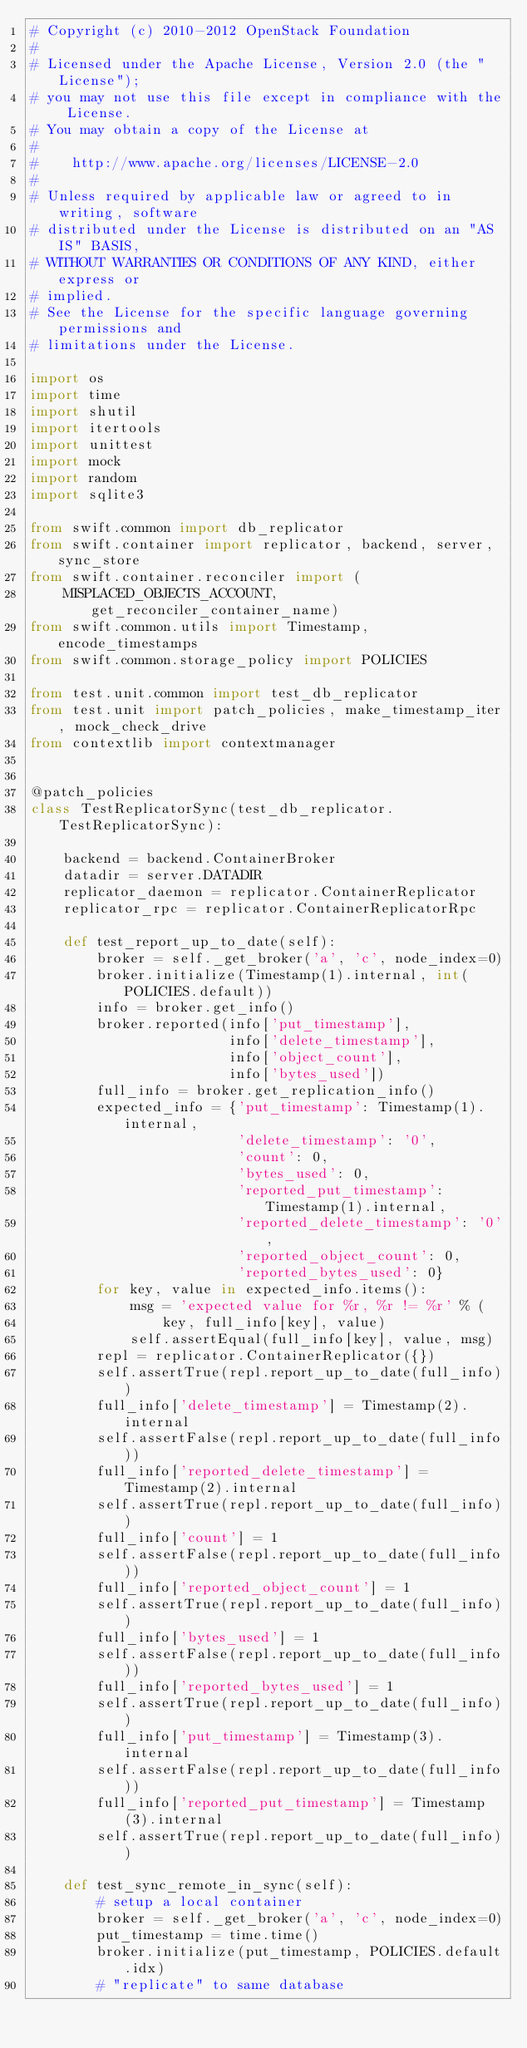Convert code to text. <code><loc_0><loc_0><loc_500><loc_500><_Python_># Copyright (c) 2010-2012 OpenStack Foundation
#
# Licensed under the Apache License, Version 2.0 (the "License");
# you may not use this file except in compliance with the License.
# You may obtain a copy of the License at
#
#    http://www.apache.org/licenses/LICENSE-2.0
#
# Unless required by applicable law or agreed to in writing, software
# distributed under the License is distributed on an "AS IS" BASIS,
# WITHOUT WARRANTIES OR CONDITIONS OF ANY KIND, either express or
# implied.
# See the License for the specific language governing permissions and
# limitations under the License.

import os
import time
import shutil
import itertools
import unittest
import mock
import random
import sqlite3

from swift.common import db_replicator
from swift.container import replicator, backend, server, sync_store
from swift.container.reconciler import (
    MISPLACED_OBJECTS_ACCOUNT, get_reconciler_container_name)
from swift.common.utils import Timestamp, encode_timestamps
from swift.common.storage_policy import POLICIES

from test.unit.common import test_db_replicator
from test.unit import patch_policies, make_timestamp_iter, mock_check_drive
from contextlib import contextmanager


@patch_policies
class TestReplicatorSync(test_db_replicator.TestReplicatorSync):

    backend = backend.ContainerBroker
    datadir = server.DATADIR
    replicator_daemon = replicator.ContainerReplicator
    replicator_rpc = replicator.ContainerReplicatorRpc

    def test_report_up_to_date(self):
        broker = self._get_broker('a', 'c', node_index=0)
        broker.initialize(Timestamp(1).internal, int(POLICIES.default))
        info = broker.get_info()
        broker.reported(info['put_timestamp'],
                        info['delete_timestamp'],
                        info['object_count'],
                        info['bytes_used'])
        full_info = broker.get_replication_info()
        expected_info = {'put_timestamp': Timestamp(1).internal,
                         'delete_timestamp': '0',
                         'count': 0,
                         'bytes_used': 0,
                         'reported_put_timestamp': Timestamp(1).internal,
                         'reported_delete_timestamp': '0',
                         'reported_object_count': 0,
                         'reported_bytes_used': 0}
        for key, value in expected_info.items():
            msg = 'expected value for %r, %r != %r' % (
                key, full_info[key], value)
            self.assertEqual(full_info[key], value, msg)
        repl = replicator.ContainerReplicator({})
        self.assertTrue(repl.report_up_to_date(full_info))
        full_info['delete_timestamp'] = Timestamp(2).internal
        self.assertFalse(repl.report_up_to_date(full_info))
        full_info['reported_delete_timestamp'] = Timestamp(2).internal
        self.assertTrue(repl.report_up_to_date(full_info))
        full_info['count'] = 1
        self.assertFalse(repl.report_up_to_date(full_info))
        full_info['reported_object_count'] = 1
        self.assertTrue(repl.report_up_to_date(full_info))
        full_info['bytes_used'] = 1
        self.assertFalse(repl.report_up_to_date(full_info))
        full_info['reported_bytes_used'] = 1
        self.assertTrue(repl.report_up_to_date(full_info))
        full_info['put_timestamp'] = Timestamp(3).internal
        self.assertFalse(repl.report_up_to_date(full_info))
        full_info['reported_put_timestamp'] = Timestamp(3).internal
        self.assertTrue(repl.report_up_to_date(full_info))

    def test_sync_remote_in_sync(self):
        # setup a local container
        broker = self._get_broker('a', 'c', node_index=0)
        put_timestamp = time.time()
        broker.initialize(put_timestamp, POLICIES.default.idx)
        # "replicate" to same database</code> 